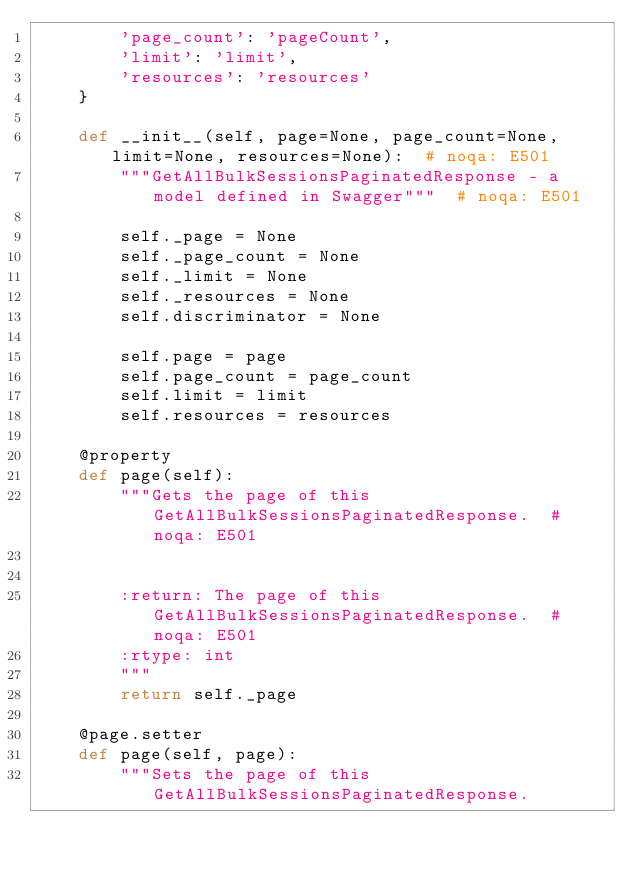Convert code to text. <code><loc_0><loc_0><loc_500><loc_500><_Python_>        'page_count': 'pageCount',
        'limit': 'limit',
        'resources': 'resources'
    }

    def __init__(self, page=None, page_count=None, limit=None, resources=None):  # noqa: E501
        """GetAllBulkSessionsPaginatedResponse - a model defined in Swagger"""  # noqa: E501

        self._page = None
        self._page_count = None
        self._limit = None
        self._resources = None
        self.discriminator = None

        self.page = page
        self.page_count = page_count
        self.limit = limit
        self.resources = resources

    @property
    def page(self):
        """Gets the page of this GetAllBulkSessionsPaginatedResponse.  # noqa: E501


        :return: The page of this GetAllBulkSessionsPaginatedResponse.  # noqa: E501
        :rtype: int
        """
        return self._page

    @page.setter
    def page(self, page):
        """Sets the page of this GetAllBulkSessionsPaginatedResponse.

</code> 